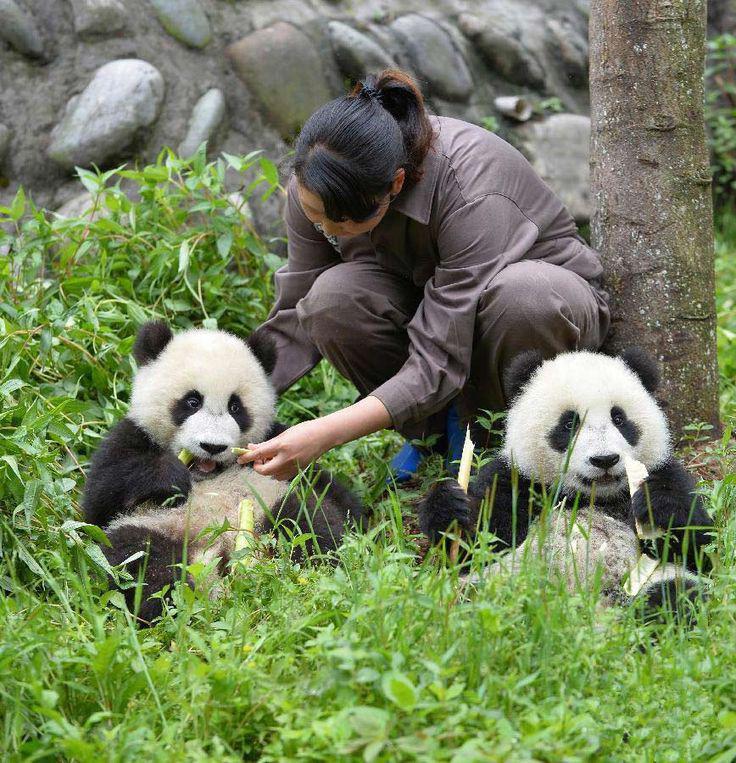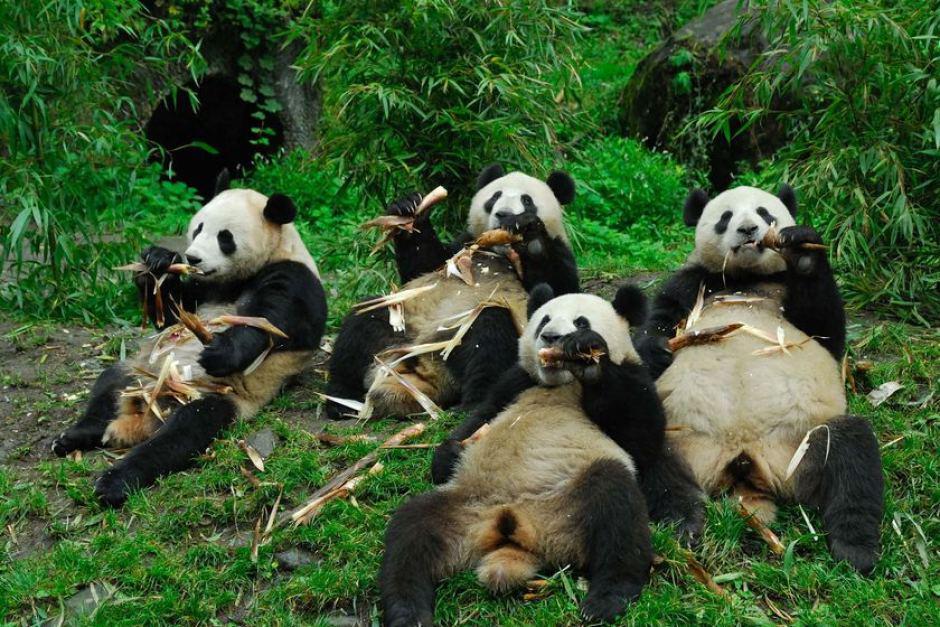The first image is the image on the left, the second image is the image on the right. Analyze the images presented: Is the assertion "Each panda in the image, whose mouth can clearly be seen, is currently eating bamboo." valid? Answer yes or no. No. 